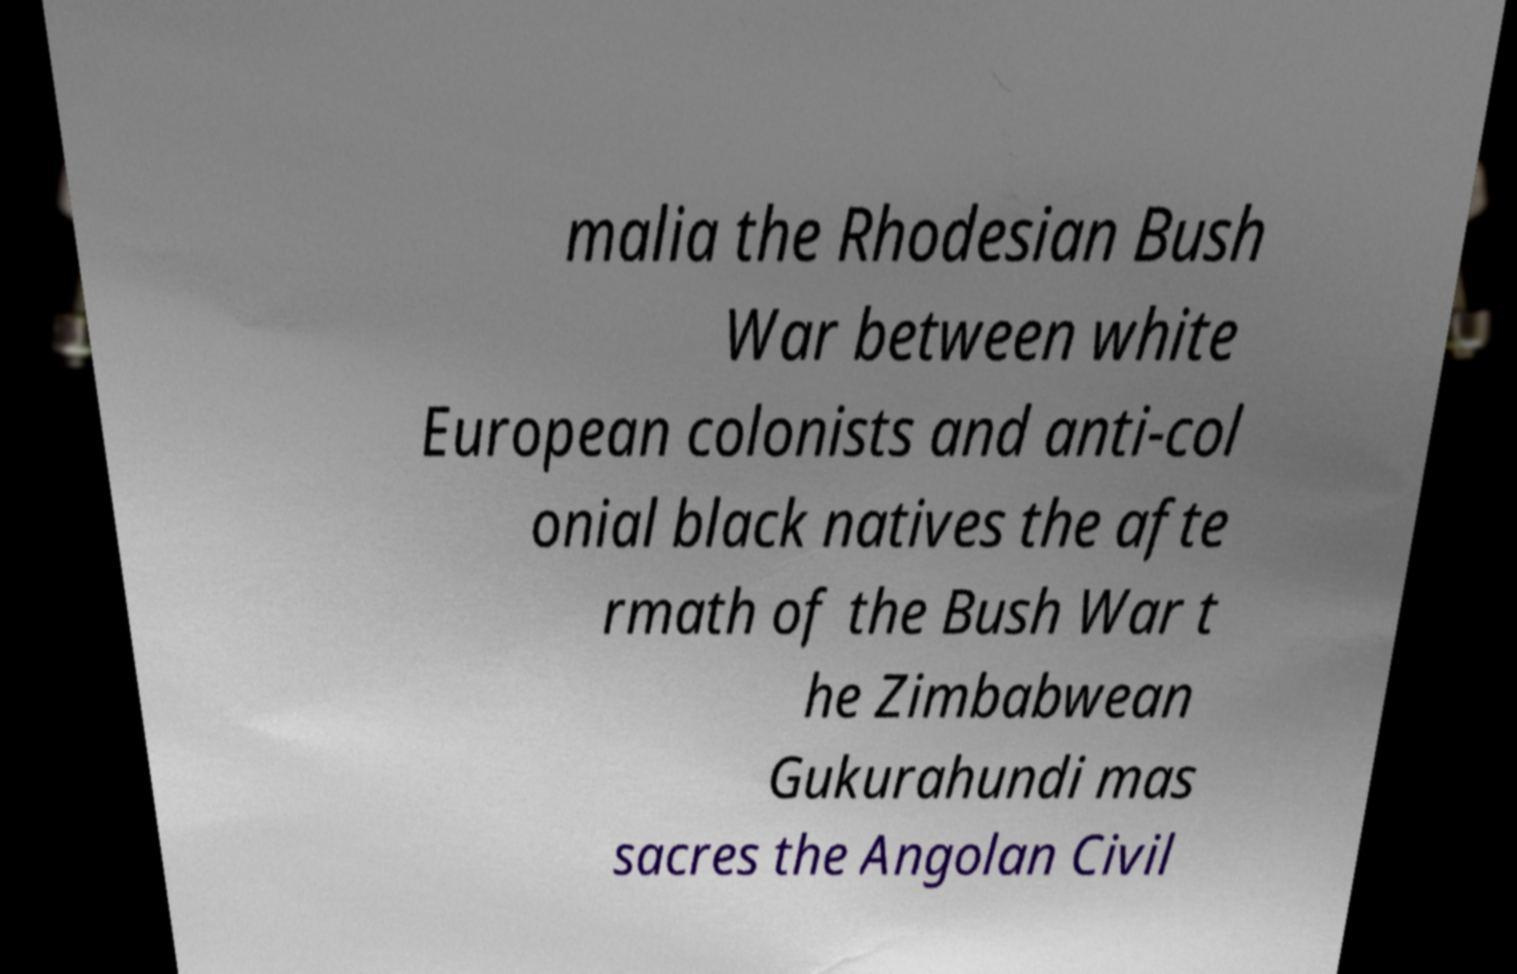For documentation purposes, I need the text within this image transcribed. Could you provide that? malia the Rhodesian Bush War between white European colonists and anti-col onial black natives the afte rmath of the Bush War t he Zimbabwean Gukurahundi mas sacres the Angolan Civil 